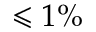<formula> <loc_0><loc_0><loc_500><loc_500>\leqslant 1 \%</formula> 